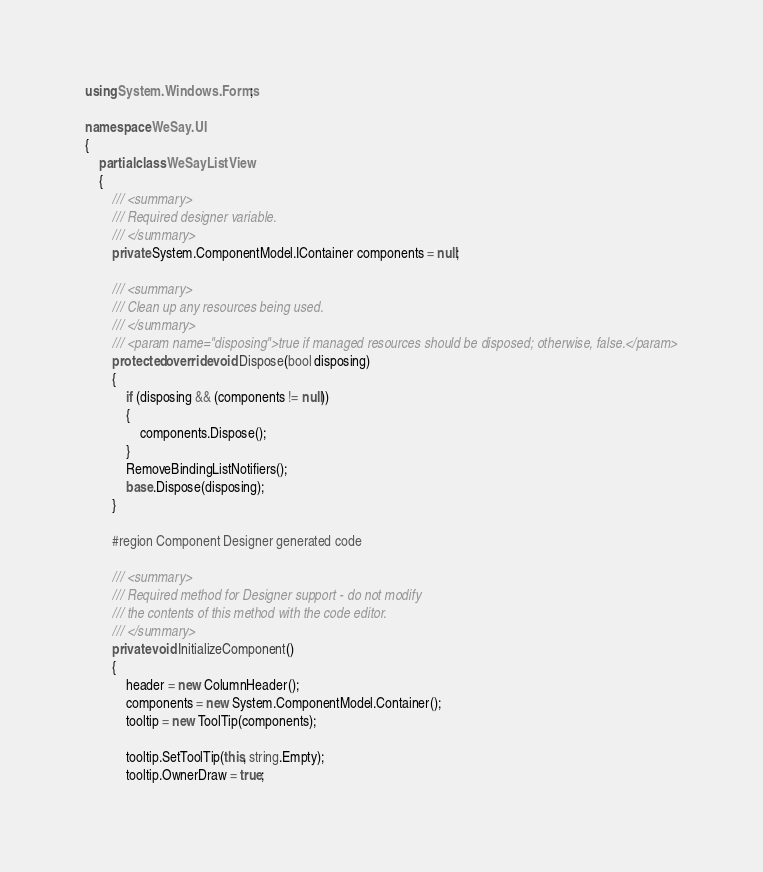<code> <loc_0><loc_0><loc_500><loc_500><_C#_>using System.Windows.Forms;

namespace WeSay.UI
{
	partial class WeSayListView
	{
		/// <summary>
		/// Required designer variable.
		/// </summary>
		private System.ComponentModel.IContainer components = null;

		/// <summary>
		/// Clean up any resources being used.
		/// </summary>
		/// <param name="disposing">true if managed resources should be disposed; otherwise, false.</param>
		protected override void Dispose(bool disposing)
		{
			if (disposing && (components != null))
			{
				components.Dispose();
			}
			RemoveBindingListNotifiers();
			base.Dispose(disposing);
		}

		#region Component Designer generated code

		/// <summary>
		/// Required method for Designer support - do not modify
		/// the contents of this method with the code editor.
		/// </summary>
		private void InitializeComponent()
		{
			header = new ColumnHeader();
			components = new System.ComponentModel.Container();
			tooltip = new ToolTip(components);

			tooltip.SetToolTip(this, string.Empty);
			tooltip.OwnerDraw = true;</code> 